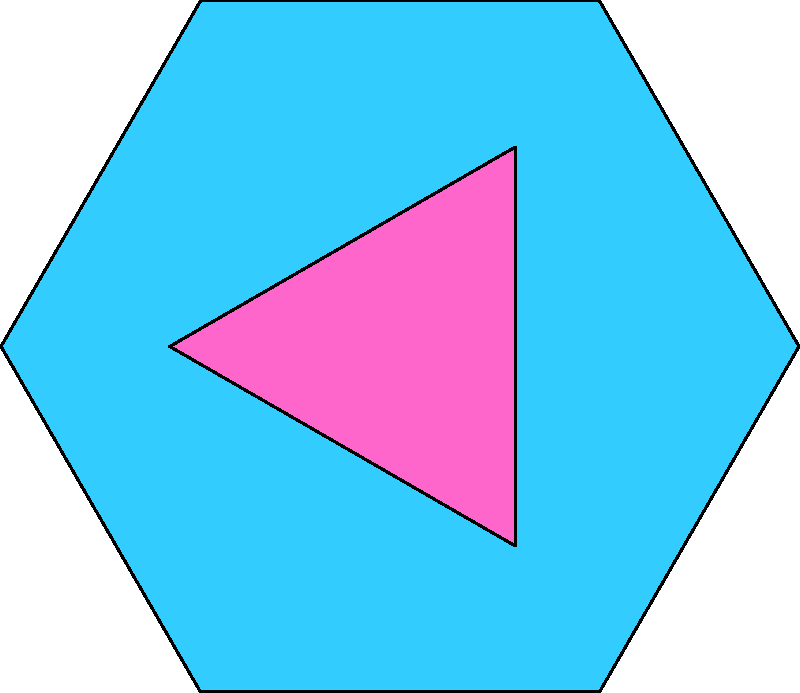A futuristic dance floor is designed with a tessellated pattern of regular hexagons and equilateral triangles, as shown in the diagram. If the side length of each hexagon is 3 meters, calculate:

a) The area of one hexagon
b) The area of one triangle
c) The total area of the pattern shown (6 hexagons and 6 triangles)

Round your answers to two decimal places. Let's approach this step-by-step:

1) For a regular hexagon with side length $s$:
   Area = $\frac{3\sqrt{3}}{2}s^2$

   With $s = 3$ meters:
   Area of hexagon = $\frac{3\sqrt{3}}{2}(3^2) = \frac{27\sqrt{3}}{2} \approx 23.38$ m²

2) The triangles are equilateral and fit exactly between two adjacent hexagon sides.
   Their side length is equal to the distance between parallel sides of the hexagon.
   For a hexagon with side $s$, this distance is $s\sqrt{3}$.

   Area of equilateral triangle = $\frac{\sqrt{3}}{4}a^2$, where $a$ is the side length.
   
   Here, $a = 3\sqrt{3}$
   Area of triangle = $\frac{\sqrt{3}}{4}(3\sqrt{3})^2 = \frac{27}{4}3 = 20.25$ m²

3) Total area = (6 × Area of hexagon) + (6 × Area of triangle)
               = $6(23.38) + 6(20.25)$
               = $140.28 + 121.50$
               = $261.78$ m²
Answer: a) 23.38 m²
b) 20.25 m²
c) 261.78 m² 